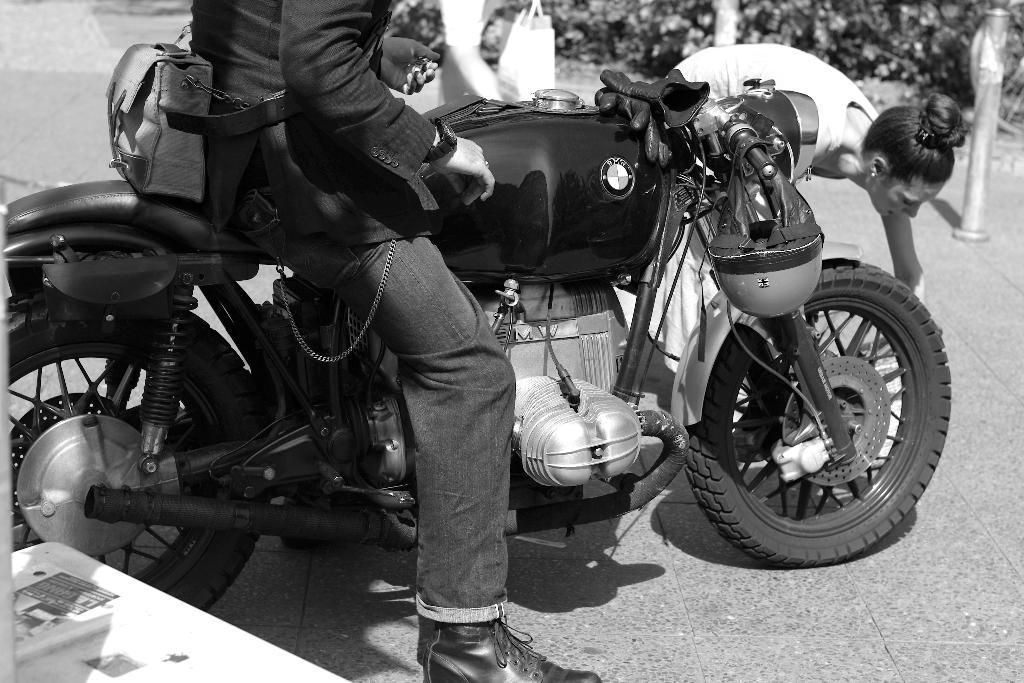Could you give a brief overview of what you see in this image? In this image we can see a person sitting on a motorcycle. Here we can observe a woman picking something from ground. 